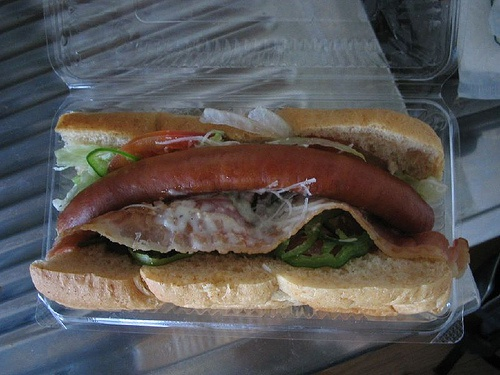Describe the objects in this image and their specific colors. I can see a hot dog in black, maroon, and gray tones in this image. 